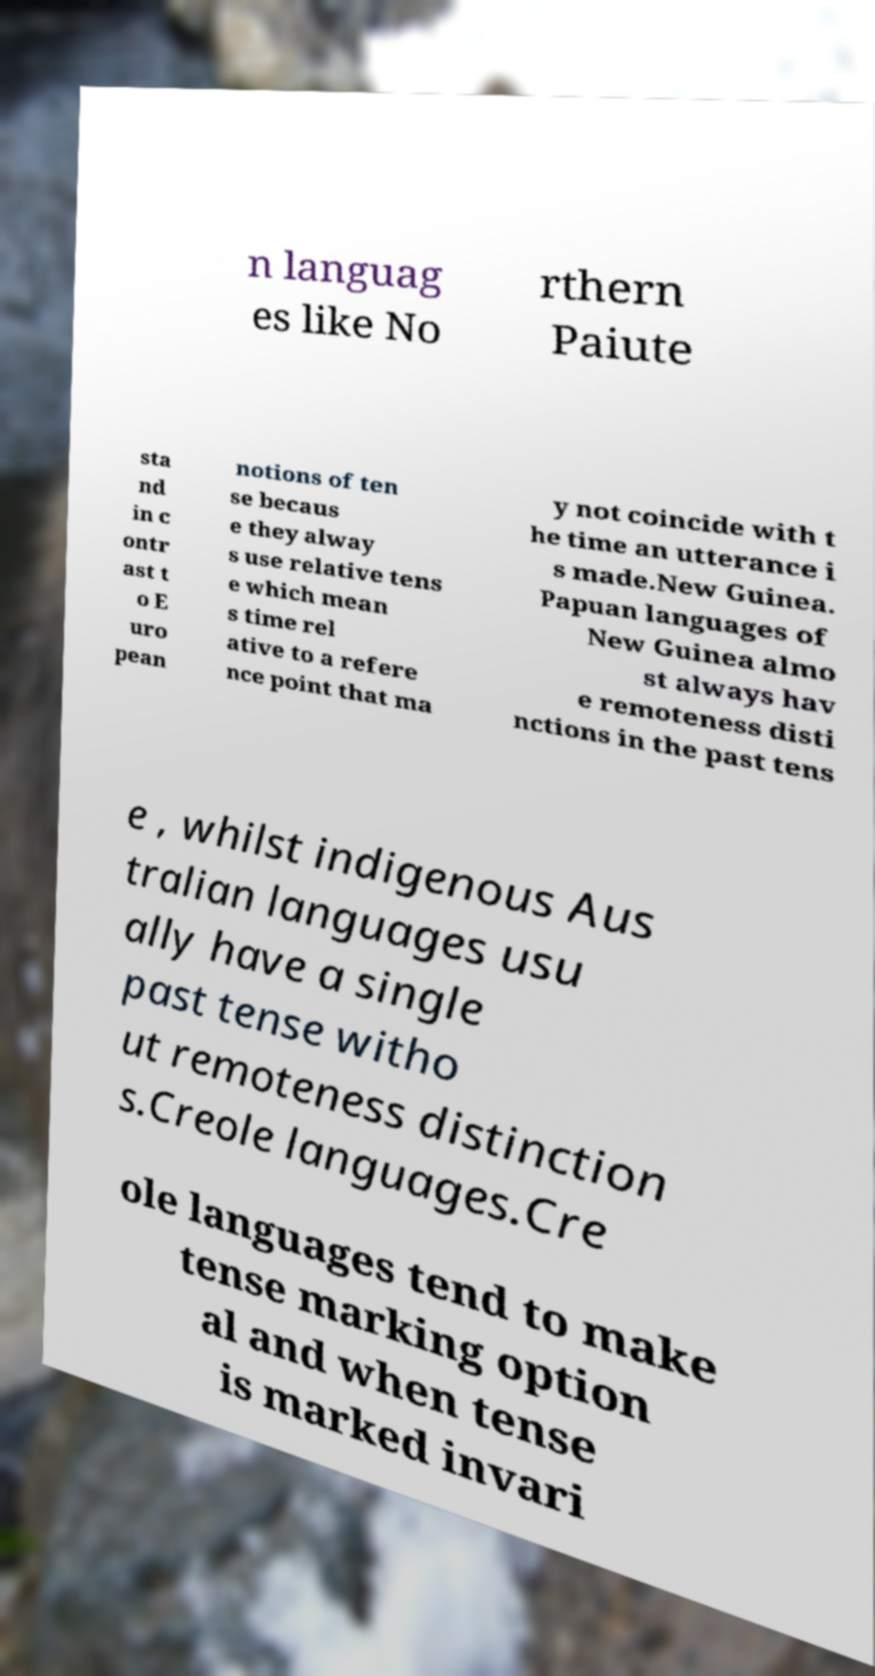Could you extract and type out the text from this image? n languag es like No rthern Paiute sta nd in c ontr ast t o E uro pean notions of ten se becaus e they alway s use relative tens e which mean s time rel ative to a refere nce point that ma y not coincide with t he time an utterance i s made.New Guinea. Papuan languages of New Guinea almo st always hav e remoteness disti nctions in the past tens e , whilst indigenous Aus tralian languages usu ally have a single past tense witho ut remoteness distinction s.Creole languages.Cre ole languages tend to make tense marking option al and when tense is marked invari 